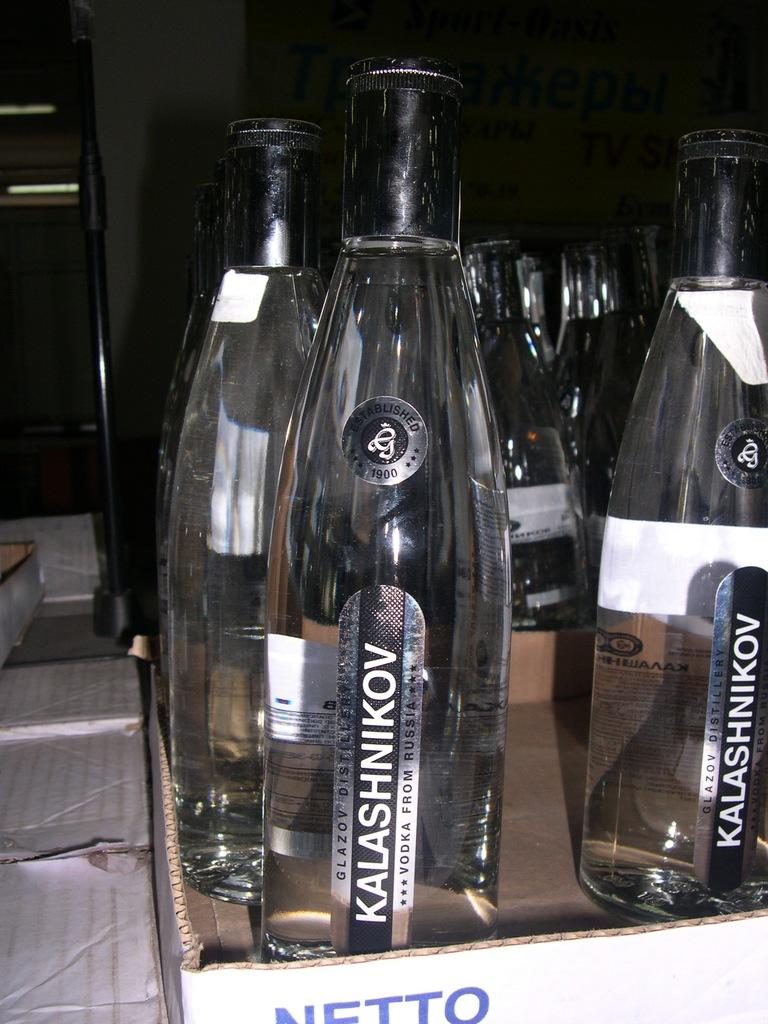Provide a one-sentence caption for the provided image. A row of Kalashnikov alcohol from Russia are waiting to be served. 